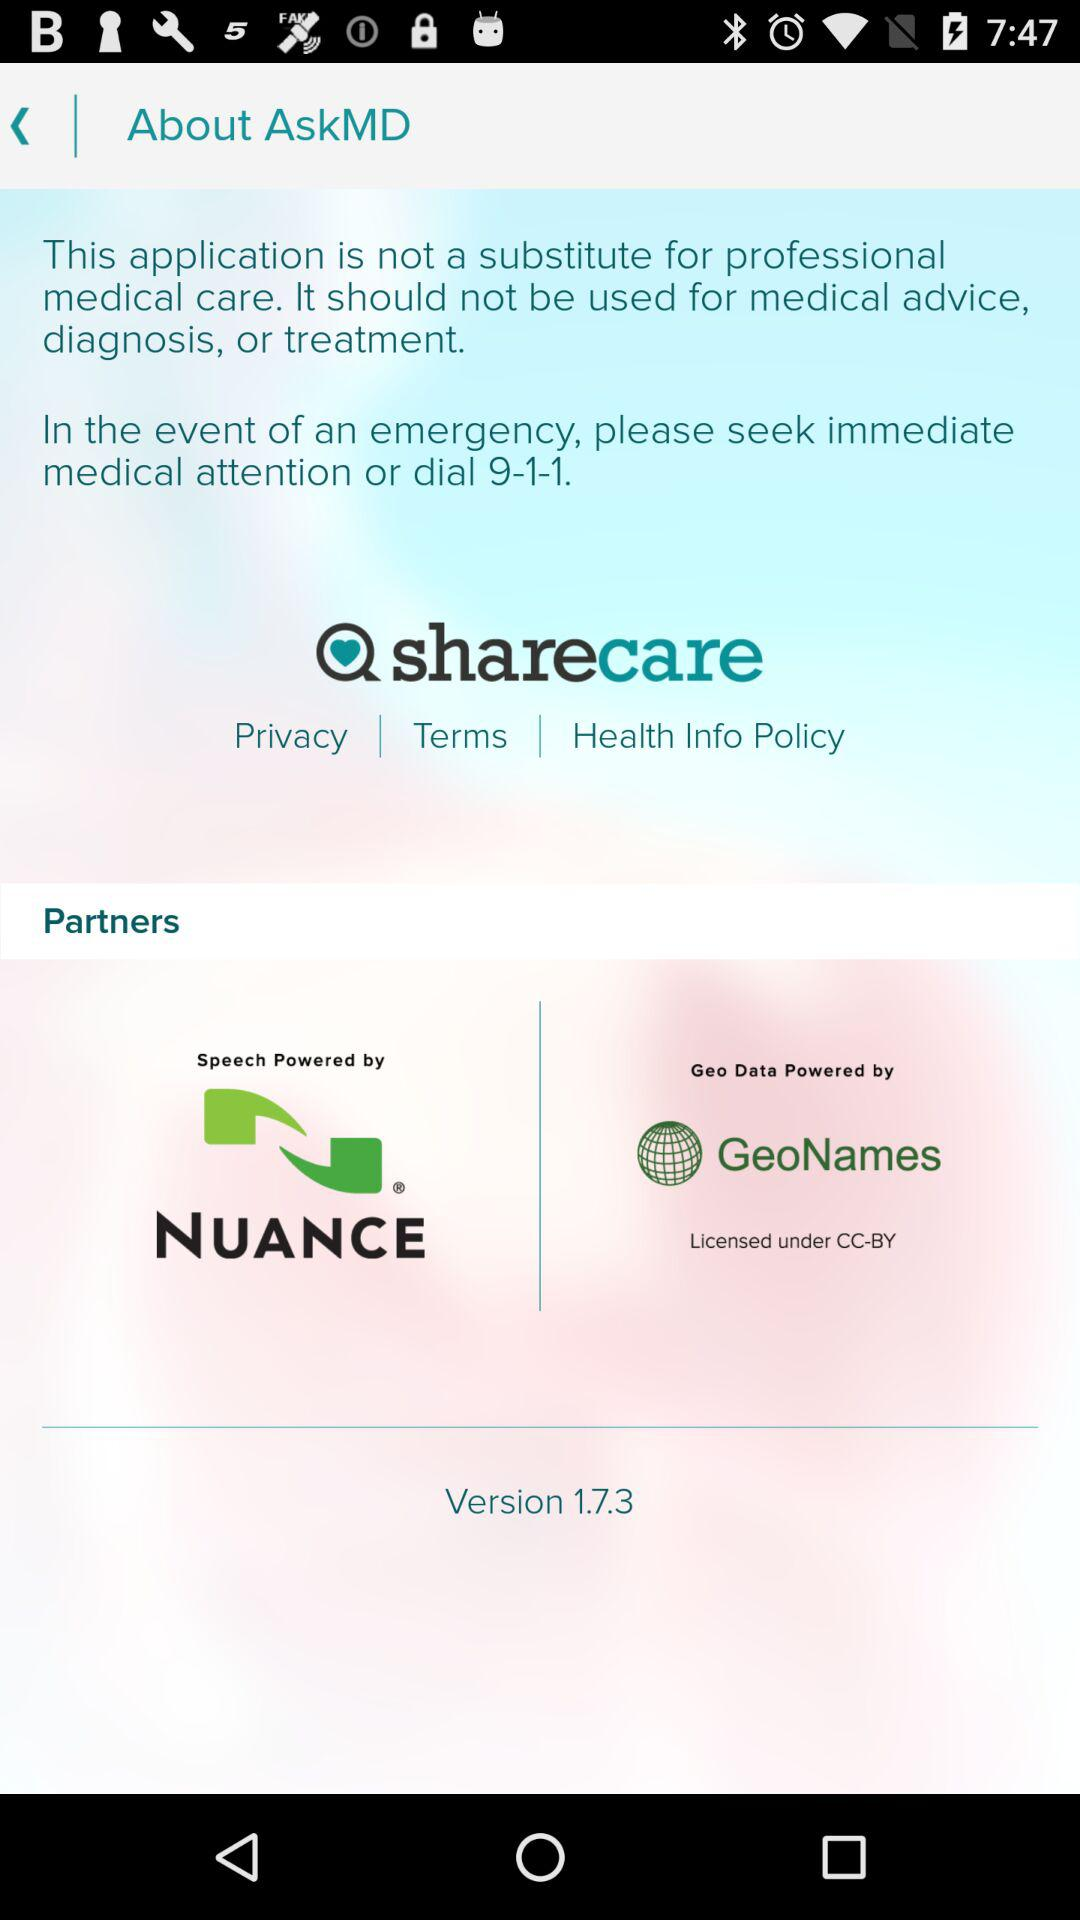What is the name of the application? The name of the application is "AskMD". 